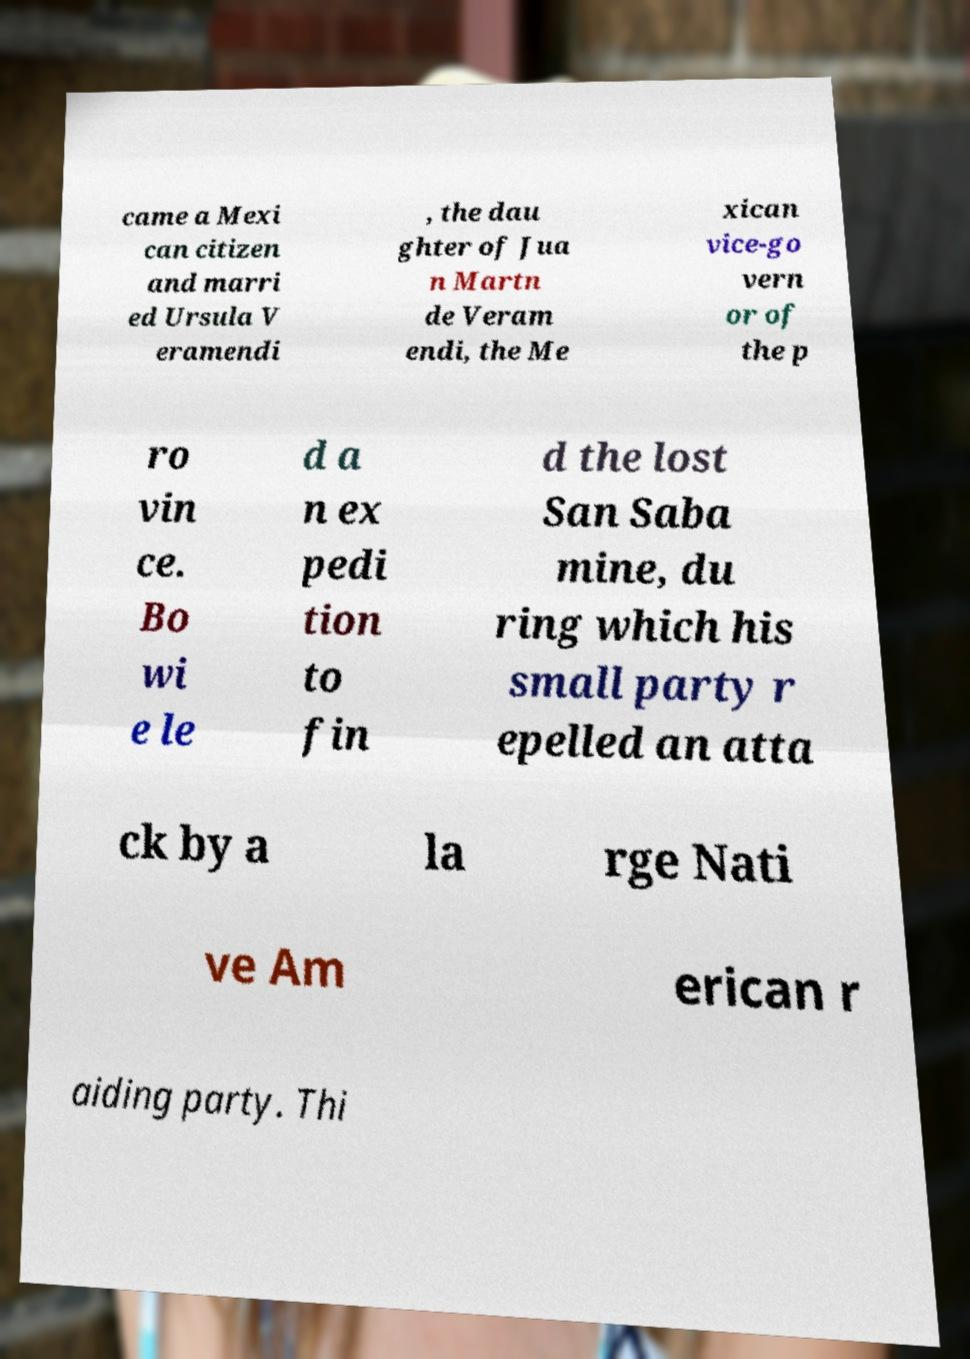I need the written content from this picture converted into text. Can you do that? came a Mexi can citizen and marri ed Ursula V eramendi , the dau ghter of Jua n Martn de Veram endi, the Me xican vice-go vern or of the p ro vin ce. Bo wi e le d a n ex pedi tion to fin d the lost San Saba mine, du ring which his small party r epelled an atta ck by a la rge Nati ve Am erican r aiding party. Thi 